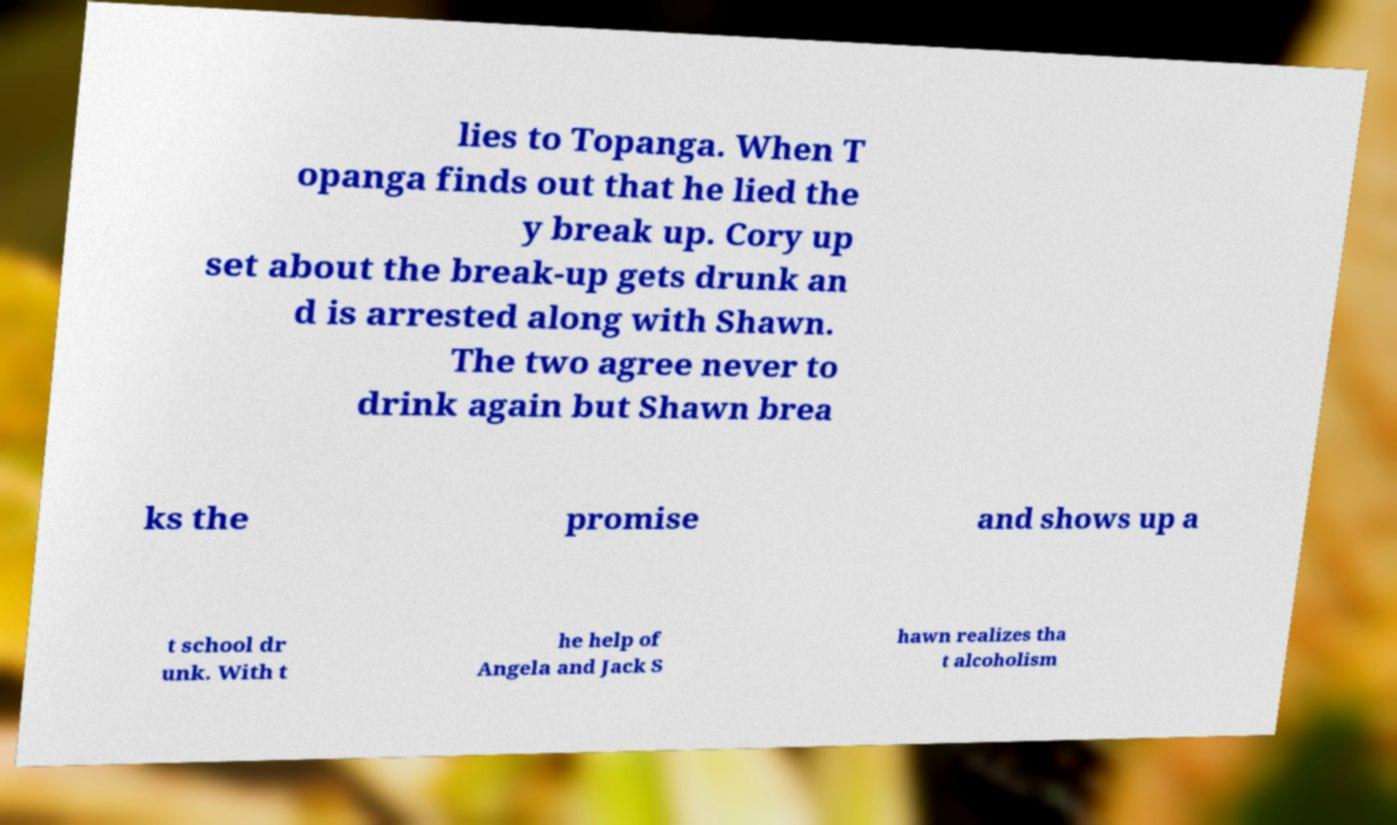Could you assist in decoding the text presented in this image and type it out clearly? lies to Topanga. When T opanga finds out that he lied the y break up. Cory up set about the break-up gets drunk an d is arrested along with Shawn. The two agree never to drink again but Shawn brea ks the promise and shows up a t school dr unk. With t he help of Angela and Jack S hawn realizes tha t alcoholism 